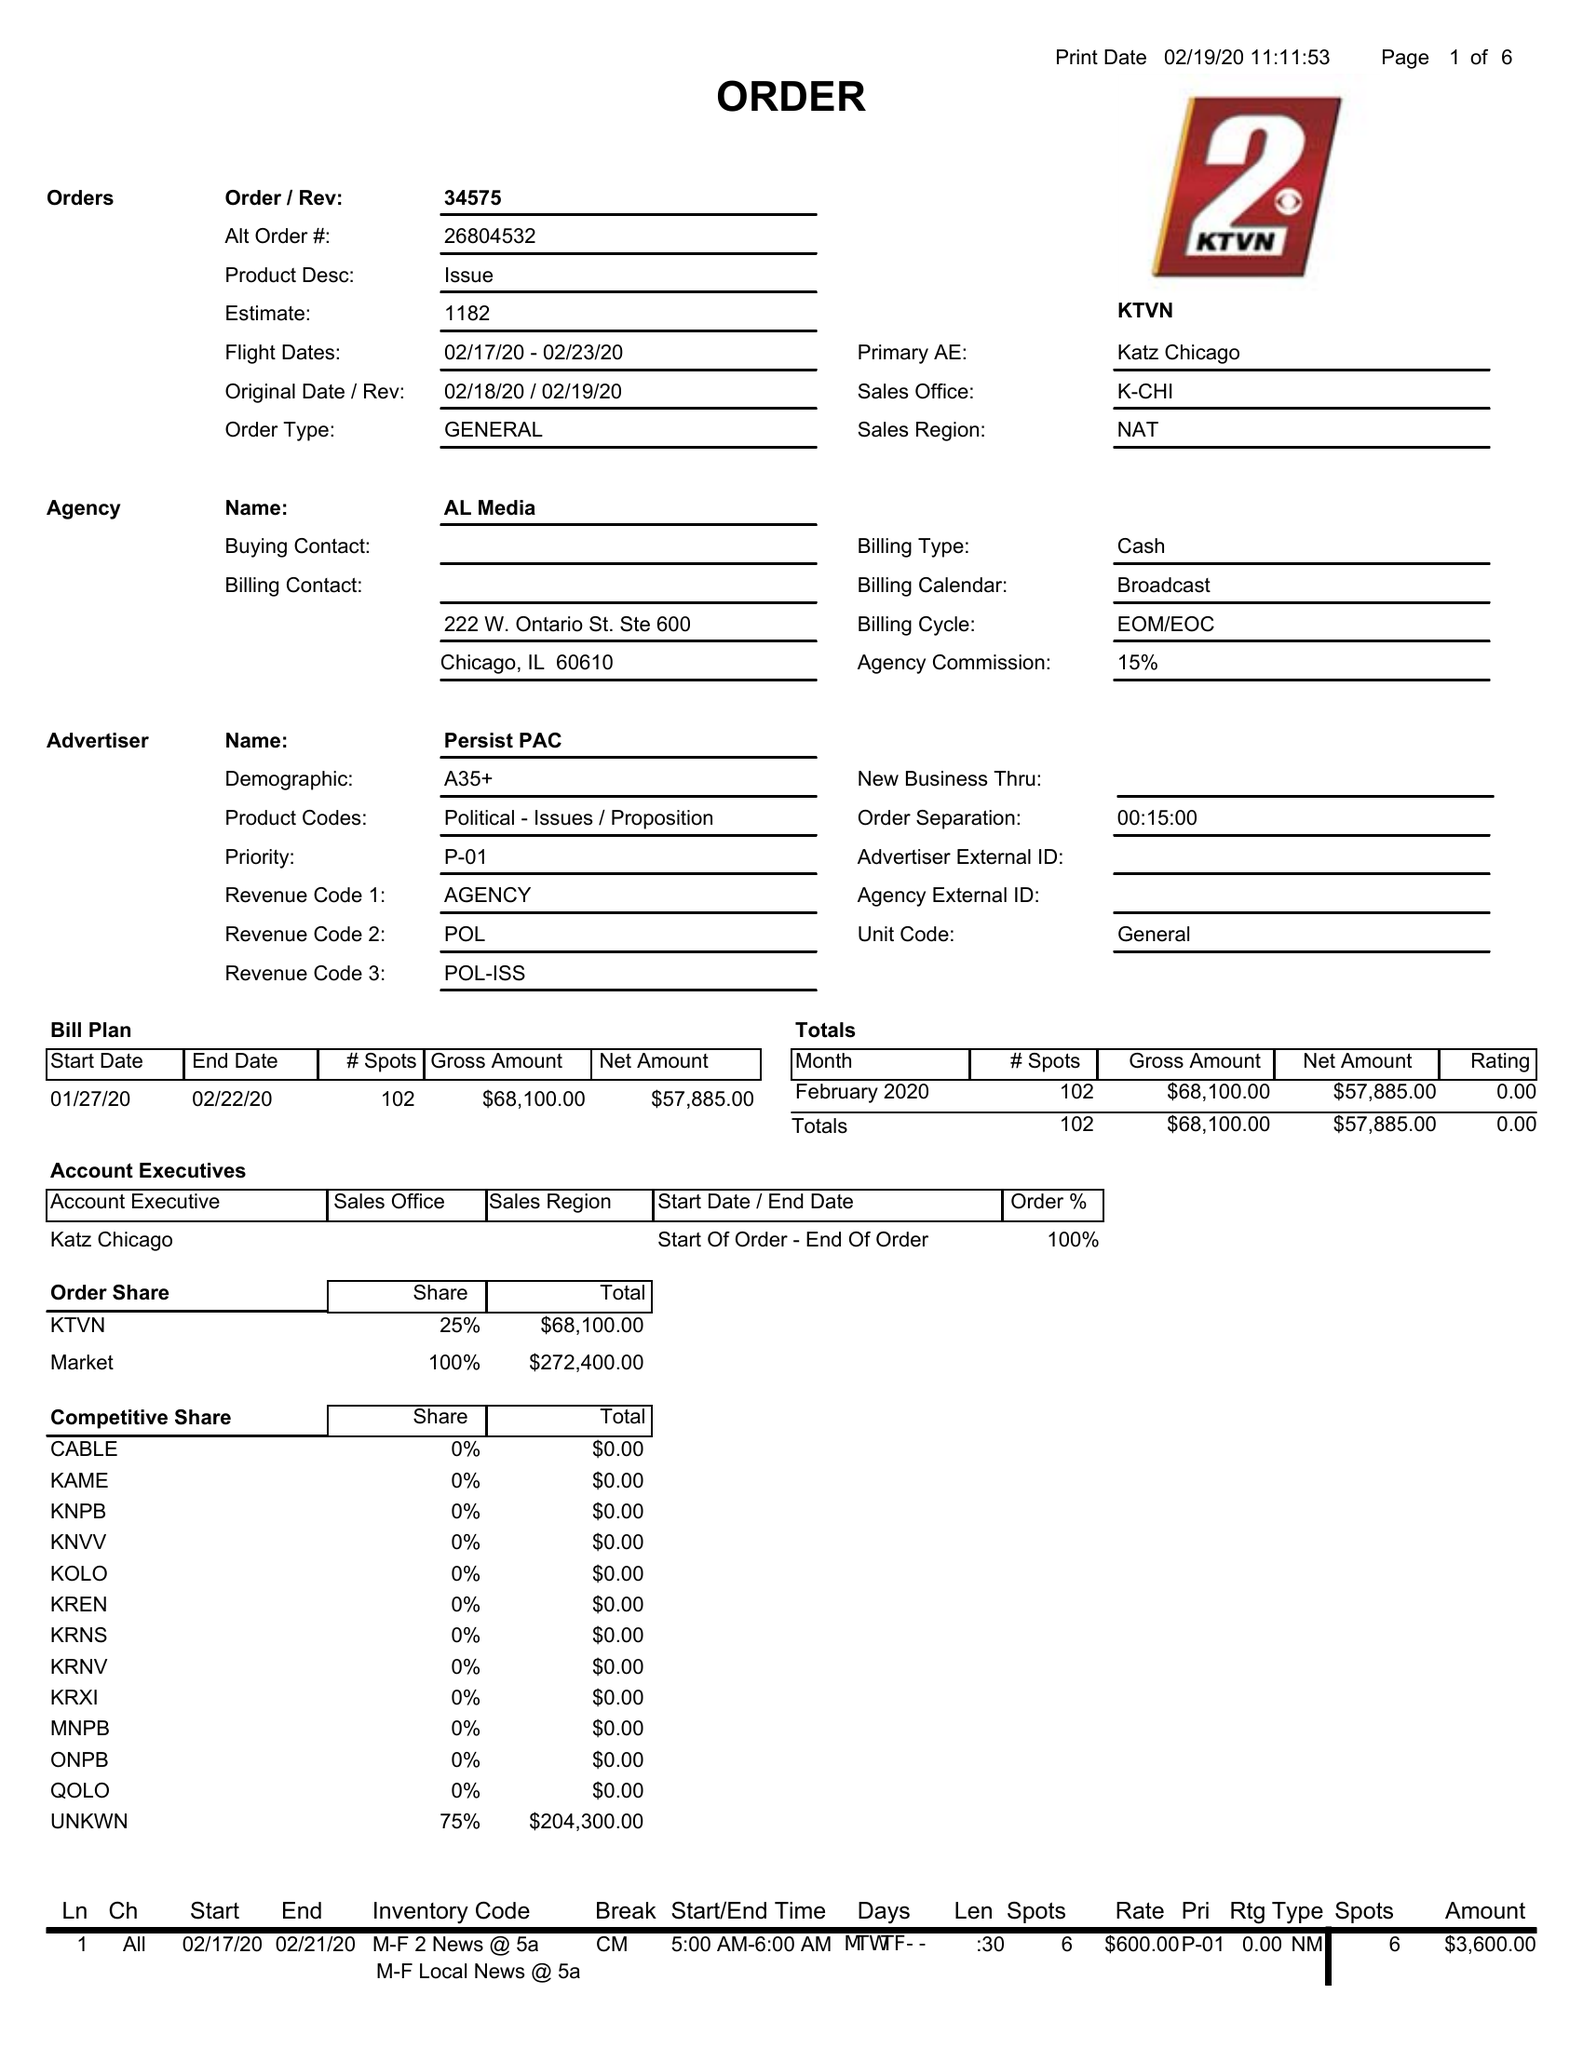What is the value for the gross_amount?
Answer the question using a single word or phrase. 68100.00 